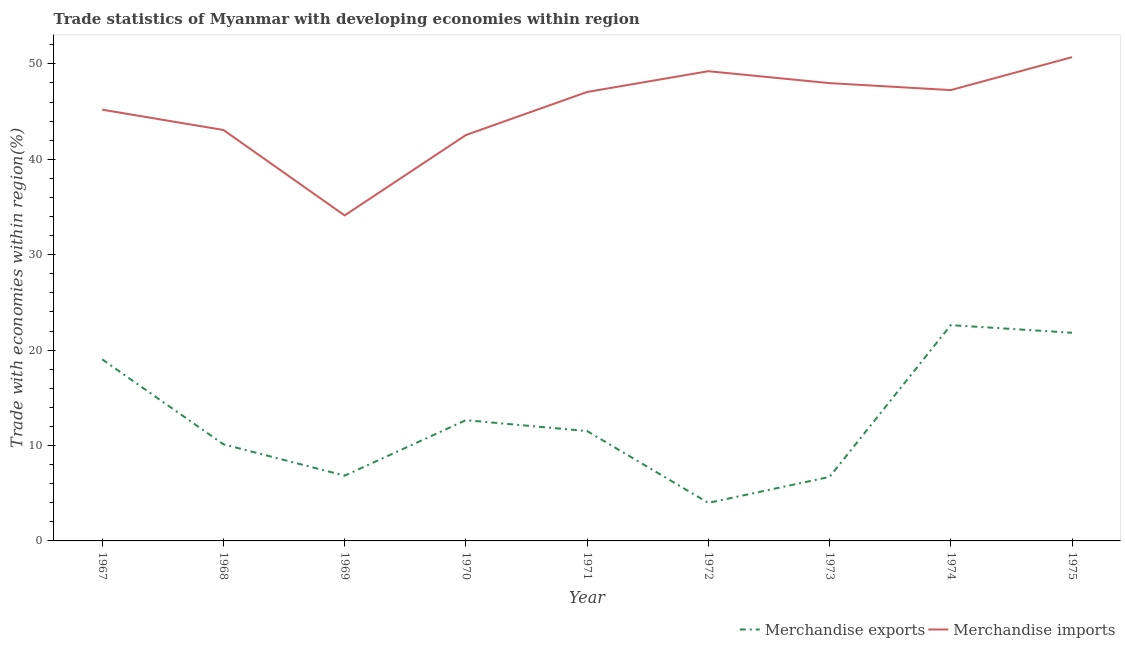Does the line corresponding to merchandise imports intersect with the line corresponding to merchandise exports?
Your response must be concise. No. What is the merchandise exports in 1970?
Keep it short and to the point. 12.65. Across all years, what is the maximum merchandise exports?
Provide a short and direct response. 22.62. Across all years, what is the minimum merchandise imports?
Your response must be concise. 34.12. In which year was the merchandise exports maximum?
Provide a short and direct response. 1974. In which year was the merchandise imports minimum?
Give a very brief answer. 1969. What is the total merchandise imports in the graph?
Offer a terse response. 407.14. What is the difference between the merchandise imports in 1971 and that in 1972?
Offer a very short reply. -2.18. What is the difference between the merchandise exports in 1971 and the merchandise imports in 1970?
Provide a short and direct response. -31.02. What is the average merchandise exports per year?
Your answer should be very brief. 12.81. In the year 1967, what is the difference between the merchandise exports and merchandise imports?
Your answer should be very brief. -26.17. What is the ratio of the merchandise exports in 1969 to that in 1975?
Your answer should be very brief. 0.31. Is the merchandise imports in 1968 less than that in 1975?
Your answer should be very brief. Yes. What is the difference between the highest and the second highest merchandise exports?
Provide a short and direct response. 0.8. What is the difference between the highest and the lowest merchandise exports?
Your answer should be very brief. 18.63. In how many years, is the merchandise imports greater than the average merchandise imports taken over all years?
Your answer should be compact. 5. Is the sum of the merchandise exports in 1967 and 1973 greater than the maximum merchandise imports across all years?
Offer a very short reply. No. Does the merchandise imports monotonically increase over the years?
Provide a succinct answer. No. Is the merchandise exports strictly less than the merchandise imports over the years?
Your answer should be very brief. Yes. How many years are there in the graph?
Ensure brevity in your answer.  9. What is the difference between two consecutive major ticks on the Y-axis?
Your answer should be very brief. 10. How are the legend labels stacked?
Your answer should be very brief. Horizontal. What is the title of the graph?
Offer a terse response. Trade statistics of Myanmar with developing economies within region. What is the label or title of the X-axis?
Your answer should be compact. Year. What is the label or title of the Y-axis?
Make the answer very short. Trade with economies within region(%). What is the Trade with economies within region(%) in Merchandise exports in 1967?
Keep it short and to the point. 19.03. What is the Trade with economies within region(%) in Merchandise imports in 1967?
Provide a short and direct response. 45.2. What is the Trade with economies within region(%) of Merchandise exports in 1968?
Your answer should be compact. 10.13. What is the Trade with economies within region(%) of Merchandise imports in 1968?
Offer a very short reply. 43.07. What is the Trade with economies within region(%) in Merchandise exports in 1969?
Provide a short and direct response. 6.84. What is the Trade with economies within region(%) in Merchandise imports in 1969?
Ensure brevity in your answer.  34.12. What is the Trade with economies within region(%) in Merchandise exports in 1970?
Your answer should be very brief. 12.65. What is the Trade with economies within region(%) in Merchandise imports in 1970?
Ensure brevity in your answer.  42.54. What is the Trade with economies within region(%) of Merchandise exports in 1971?
Provide a short and direct response. 11.52. What is the Trade with economies within region(%) in Merchandise imports in 1971?
Your answer should be very brief. 47.05. What is the Trade with economies within region(%) of Merchandise exports in 1972?
Your answer should be compact. 3.99. What is the Trade with economies within region(%) of Merchandise imports in 1972?
Provide a short and direct response. 49.23. What is the Trade with economies within region(%) in Merchandise exports in 1973?
Your response must be concise. 6.71. What is the Trade with economies within region(%) of Merchandise imports in 1973?
Offer a terse response. 47.98. What is the Trade with economies within region(%) of Merchandise exports in 1974?
Provide a short and direct response. 22.62. What is the Trade with economies within region(%) of Merchandise imports in 1974?
Your answer should be very brief. 47.25. What is the Trade with economies within region(%) of Merchandise exports in 1975?
Provide a short and direct response. 21.82. What is the Trade with economies within region(%) of Merchandise imports in 1975?
Your response must be concise. 50.7. Across all years, what is the maximum Trade with economies within region(%) of Merchandise exports?
Give a very brief answer. 22.62. Across all years, what is the maximum Trade with economies within region(%) in Merchandise imports?
Offer a very short reply. 50.7. Across all years, what is the minimum Trade with economies within region(%) of Merchandise exports?
Offer a terse response. 3.99. Across all years, what is the minimum Trade with economies within region(%) of Merchandise imports?
Keep it short and to the point. 34.12. What is the total Trade with economies within region(%) in Merchandise exports in the graph?
Your answer should be very brief. 115.3. What is the total Trade with economies within region(%) of Merchandise imports in the graph?
Provide a succinct answer. 407.14. What is the difference between the Trade with economies within region(%) of Merchandise exports in 1967 and that in 1968?
Keep it short and to the point. 8.9. What is the difference between the Trade with economies within region(%) in Merchandise imports in 1967 and that in 1968?
Your answer should be compact. 2.13. What is the difference between the Trade with economies within region(%) in Merchandise exports in 1967 and that in 1969?
Provide a short and direct response. 12.19. What is the difference between the Trade with economies within region(%) in Merchandise imports in 1967 and that in 1969?
Offer a very short reply. 11.08. What is the difference between the Trade with economies within region(%) in Merchandise exports in 1967 and that in 1970?
Provide a succinct answer. 6.37. What is the difference between the Trade with economies within region(%) of Merchandise imports in 1967 and that in 1970?
Your answer should be very brief. 2.66. What is the difference between the Trade with economies within region(%) in Merchandise exports in 1967 and that in 1971?
Offer a terse response. 7.51. What is the difference between the Trade with economies within region(%) in Merchandise imports in 1967 and that in 1971?
Your answer should be very brief. -1.86. What is the difference between the Trade with economies within region(%) in Merchandise exports in 1967 and that in 1972?
Your answer should be compact. 15.04. What is the difference between the Trade with economies within region(%) in Merchandise imports in 1967 and that in 1972?
Offer a terse response. -4.03. What is the difference between the Trade with economies within region(%) in Merchandise exports in 1967 and that in 1973?
Your answer should be very brief. 12.32. What is the difference between the Trade with economies within region(%) in Merchandise imports in 1967 and that in 1973?
Your answer should be compact. -2.78. What is the difference between the Trade with economies within region(%) of Merchandise exports in 1967 and that in 1974?
Make the answer very short. -3.59. What is the difference between the Trade with economies within region(%) of Merchandise imports in 1967 and that in 1974?
Give a very brief answer. -2.05. What is the difference between the Trade with economies within region(%) of Merchandise exports in 1967 and that in 1975?
Your response must be concise. -2.79. What is the difference between the Trade with economies within region(%) of Merchandise imports in 1967 and that in 1975?
Make the answer very short. -5.5. What is the difference between the Trade with economies within region(%) of Merchandise exports in 1968 and that in 1969?
Your answer should be very brief. 3.29. What is the difference between the Trade with economies within region(%) of Merchandise imports in 1968 and that in 1969?
Your response must be concise. 8.96. What is the difference between the Trade with economies within region(%) in Merchandise exports in 1968 and that in 1970?
Make the answer very short. -2.53. What is the difference between the Trade with economies within region(%) of Merchandise imports in 1968 and that in 1970?
Your answer should be very brief. 0.53. What is the difference between the Trade with economies within region(%) of Merchandise exports in 1968 and that in 1971?
Your response must be concise. -1.39. What is the difference between the Trade with economies within region(%) in Merchandise imports in 1968 and that in 1971?
Give a very brief answer. -3.98. What is the difference between the Trade with economies within region(%) in Merchandise exports in 1968 and that in 1972?
Keep it short and to the point. 6.14. What is the difference between the Trade with economies within region(%) of Merchandise imports in 1968 and that in 1972?
Offer a very short reply. -6.16. What is the difference between the Trade with economies within region(%) of Merchandise exports in 1968 and that in 1973?
Ensure brevity in your answer.  3.42. What is the difference between the Trade with economies within region(%) of Merchandise imports in 1968 and that in 1973?
Your answer should be compact. -4.91. What is the difference between the Trade with economies within region(%) in Merchandise exports in 1968 and that in 1974?
Keep it short and to the point. -12.49. What is the difference between the Trade with economies within region(%) of Merchandise imports in 1968 and that in 1974?
Make the answer very short. -4.18. What is the difference between the Trade with economies within region(%) of Merchandise exports in 1968 and that in 1975?
Ensure brevity in your answer.  -11.69. What is the difference between the Trade with economies within region(%) in Merchandise imports in 1968 and that in 1975?
Provide a succinct answer. -7.63. What is the difference between the Trade with economies within region(%) in Merchandise exports in 1969 and that in 1970?
Keep it short and to the point. -5.82. What is the difference between the Trade with economies within region(%) in Merchandise imports in 1969 and that in 1970?
Ensure brevity in your answer.  -8.42. What is the difference between the Trade with economies within region(%) of Merchandise exports in 1969 and that in 1971?
Your response must be concise. -4.68. What is the difference between the Trade with economies within region(%) of Merchandise imports in 1969 and that in 1971?
Provide a short and direct response. -12.94. What is the difference between the Trade with economies within region(%) in Merchandise exports in 1969 and that in 1972?
Offer a terse response. 2.85. What is the difference between the Trade with economies within region(%) in Merchandise imports in 1969 and that in 1972?
Make the answer very short. -15.11. What is the difference between the Trade with economies within region(%) of Merchandise exports in 1969 and that in 1973?
Offer a very short reply. 0.13. What is the difference between the Trade with economies within region(%) of Merchandise imports in 1969 and that in 1973?
Your answer should be very brief. -13.86. What is the difference between the Trade with economies within region(%) of Merchandise exports in 1969 and that in 1974?
Keep it short and to the point. -15.78. What is the difference between the Trade with economies within region(%) in Merchandise imports in 1969 and that in 1974?
Ensure brevity in your answer.  -13.14. What is the difference between the Trade with economies within region(%) in Merchandise exports in 1969 and that in 1975?
Ensure brevity in your answer.  -14.98. What is the difference between the Trade with economies within region(%) in Merchandise imports in 1969 and that in 1975?
Offer a very short reply. -16.59. What is the difference between the Trade with economies within region(%) of Merchandise exports in 1970 and that in 1971?
Ensure brevity in your answer.  1.14. What is the difference between the Trade with economies within region(%) of Merchandise imports in 1970 and that in 1971?
Your response must be concise. -4.51. What is the difference between the Trade with economies within region(%) of Merchandise exports in 1970 and that in 1972?
Your answer should be very brief. 8.67. What is the difference between the Trade with economies within region(%) in Merchandise imports in 1970 and that in 1972?
Your answer should be very brief. -6.69. What is the difference between the Trade with economies within region(%) of Merchandise exports in 1970 and that in 1973?
Provide a succinct answer. 5.94. What is the difference between the Trade with economies within region(%) of Merchandise imports in 1970 and that in 1973?
Provide a succinct answer. -5.44. What is the difference between the Trade with economies within region(%) in Merchandise exports in 1970 and that in 1974?
Give a very brief answer. -9.96. What is the difference between the Trade with economies within region(%) of Merchandise imports in 1970 and that in 1974?
Make the answer very short. -4.71. What is the difference between the Trade with economies within region(%) of Merchandise exports in 1970 and that in 1975?
Provide a succinct answer. -9.16. What is the difference between the Trade with economies within region(%) of Merchandise imports in 1970 and that in 1975?
Your response must be concise. -8.16. What is the difference between the Trade with economies within region(%) in Merchandise exports in 1971 and that in 1972?
Make the answer very short. 7.53. What is the difference between the Trade with economies within region(%) of Merchandise imports in 1971 and that in 1972?
Offer a very short reply. -2.18. What is the difference between the Trade with economies within region(%) in Merchandise exports in 1971 and that in 1973?
Your answer should be very brief. 4.8. What is the difference between the Trade with economies within region(%) in Merchandise imports in 1971 and that in 1973?
Ensure brevity in your answer.  -0.93. What is the difference between the Trade with economies within region(%) in Merchandise exports in 1971 and that in 1974?
Provide a short and direct response. -11.1. What is the difference between the Trade with economies within region(%) in Merchandise imports in 1971 and that in 1974?
Your response must be concise. -0.2. What is the difference between the Trade with economies within region(%) in Merchandise exports in 1971 and that in 1975?
Provide a succinct answer. -10.3. What is the difference between the Trade with economies within region(%) of Merchandise imports in 1971 and that in 1975?
Your answer should be very brief. -3.65. What is the difference between the Trade with economies within region(%) in Merchandise exports in 1972 and that in 1973?
Keep it short and to the point. -2.73. What is the difference between the Trade with economies within region(%) of Merchandise imports in 1972 and that in 1973?
Your response must be concise. 1.25. What is the difference between the Trade with economies within region(%) in Merchandise exports in 1972 and that in 1974?
Provide a short and direct response. -18.63. What is the difference between the Trade with economies within region(%) in Merchandise imports in 1972 and that in 1974?
Keep it short and to the point. 1.98. What is the difference between the Trade with economies within region(%) in Merchandise exports in 1972 and that in 1975?
Keep it short and to the point. -17.83. What is the difference between the Trade with economies within region(%) of Merchandise imports in 1972 and that in 1975?
Offer a very short reply. -1.47. What is the difference between the Trade with economies within region(%) in Merchandise exports in 1973 and that in 1974?
Offer a terse response. -15.9. What is the difference between the Trade with economies within region(%) of Merchandise imports in 1973 and that in 1974?
Offer a terse response. 0.73. What is the difference between the Trade with economies within region(%) of Merchandise exports in 1973 and that in 1975?
Offer a terse response. -15.11. What is the difference between the Trade with economies within region(%) in Merchandise imports in 1973 and that in 1975?
Offer a very short reply. -2.72. What is the difference between the Trade with economies within region(%) in Merchandise exports in 1974 and that in 1975?
Offer a very short reply. 0.8. What is the difference between the Trade with economies within region(%) of Merchandise imports in 1974 and that in 1975?
Make the answer very short. -3.45. What is the difference between the Trade with economies within region(%) in Merchandise exports in 1967 and the Trade with economies within region(%) in Merchandise imports in 1968?
Make the answer very short. -24.04. What is the difference between the Trade with economies within region(%) in Merchandise exports in 1967 and the Trade with economies within region(%) in Merchandise imports in 1969?
Provide a succinct answer. -15.09. What is the difference between the Trade with economies within region(%) in Merchandise exports in 1967 and the Trade with economies within region(%) in Merchandise imports in 1970?
Provide a succinct answer. -23.51. What is the difference between the Trade with economies within region(%) in Merchandise exports in 1967 and the Trade with economies within region(%) in Merchandise imports in 1971?
Ensure brevity in your answer.  -28.03. What is the difference between the Trade with economies within region(%) in Merchandise exports in 1967 and the Trade with economies within region(%) in Merchandise imports in 1972?
Offer a very short reply. -30.2. What is the difference between the Trade with economies within region(%) in Merchandise exports in 1967 and the Trade with economies within region(%) in Merchandise imports in 1973?
Your answer should be very brief. -28.95. What is the difference between the Trade with economies within region(%) of Merchandise exports in 1967 and the Trade with economies within region(%) of Merchandise imports in 1974?
Provide a succinct answer. -28.22. What is the difference between the Trade with economies within region(%) in Merchandise exports in 1967 and the Trade with economies within region(%) in Merchandise imports in 1975?
Provide a short and direct response. -31.67. What is the difference between the Trade with economies within region(%) of Merchandise exports in 1968 and the Trade with economies within region(%) of Merchandise imports in 1969?
Your answer should be very brief. -23.99. What is the difference between the Trade with economies within region(%) of Merchandise exports in 1968 and the Trade with economies within region(%) of Merchandise imports in 1970?
Keep it short and to the point. -32.41. What is the difference between the Trade with economies within region(%) of Merchandise exports in 1968 and the Trade with economies within region(%) of Merchandise imports in 1971?
Offer a very short reply. -36.93. What is the difference between the Trade with economies within region(%) in Merchandise exports in 1968 and the Trade with economies within region(%) in Merchandise imports in 1972?
Provide a short and direct response. -39.1. What is the difference between the Trade with economies within region(%) in Merchandise exports in 1968 and the Trade with economies within region(%) in Merchandise imports in 1973?
Make the answer very short. -37.85. What is the difference between the Trade with economies within region(%) in Merchandise exports in 1968 and the Trade with economies within region(%) in Merchandise imports in 1974?
Give a very brief answer. -37.12. What is the difference between the Trade with economies within region(%) of Merchandise exports in 1968 and the Trade with economies within region(%) of Merchandise imports in 1975?
Your answer should be compact. -40.57. What is the difference between the Trade with economies within region(%) of Merchandise exports in 1969 and the Trade with economies within region(%) of Merchandise imports in 1970?
Your answer should be very brief. -35.7. What is the difference between the Trade with economies within region(%) of Merchandise exports in 1969 and the Trade with economies within region(%) of Merchandise imports in 1971?
Your answer should be very brief. -40.21. What is the difference between the Trade with economies within region(%) of Merchandise exports in 1969 and the Trade with economies within region(%) of Merchandise imports in 1972?
Your response must be concise. -42.39. What is the difference between the Trade with economies within region(%) of Merchandise exports in 1969 and the Trade with economies within region(%) of Merchandise imports in 1973?
Make the answer very short. -41.14. What is the difference between the Trade with economies within region(%) of Merchandise exports in 1969 and the Trade with economies within region(%) of Merchandise imports in 1974?
Your answer should be very brief. -40.41. What is the difference between the Trade with economies within region(%) in Merchandise exports in 1969 and the Trade with economies within region(%) in Merchandise imports in 1975?
Your response must be concise. -43.86. What is the difference between the Trade with economies within region(%) of Merchandise exports in 1970 and the Trade with economies within region(%) of Merchandise imports in 1971?
Offer a very short reply. -34.4. What is the difference between the Trade with economies within region(%) of Merchandise exports in 1970 and the Trade with economies within region(%) of Merchandise imports in 1972?
Your answer should be compact. -36.58. What is the difference between the Trade with economies within region(%) in Merchandise exports in 1970 and the Trade with economies within region(%) in Merchandise imports in 1973?
Offer a very short reply. -35.33. What is the difference between the Trade with economies within region(%) of Merchandise exports in 1970 and the Trade with economies within region(%) of Merchandise imports in 1974?
Keep it short and to the point. -34.6. What is the difference between the Trade with economies within region(%) of Merchandise exports in 1970 and the Trade with economies within region(%) of Merchandise imports in 1975?
Your answer should be compact. -38.05. What is the difference between the Trade with economies within region(%) in Merchandise exports in 1971 and the Trade with economies within region(%) in Merchandise imports in 1972?
Make the answer very short. -37.71. What is the difference between the Trade with economies within region(%) in Merchandise exports in 1971 and the Trade with economies within region(%) in Merchandise imports in 1973?
Offer a terse response. -36.46. What is the difference between the Trade with economies within region(%) in Merchandise exports in 1971 and the Trade with economies within region(%) in Merchandise imports in 1974?
Offer a terse response. -35.74. What is the difference between the Trade with economies within region(%) in Merchandise exports in 1971 and the Trade with economies within region(%) in Merchandise imports in 1975?
Provide a succinct answer. -39.19. What is the difference between the Trade with economies within region(%) in Merchandise exports in 1972 and the Trade with economies within region(%) in Merchandise imports in 1973?
Make the answer very short. -43.99. What is the difference between the Trade with economies within region(%) in Merchandise exports in 1972 and the Trade with economies within region(%) in Merchandise imports in 1974?
Offer a very short reply. -43.27. What is the difference between the Trade with economies within region(%) in Merchandise exports in 1972 and the Trade with economies within region(%) in Merchandise imports in 1975?
Offer a terse response. -46.72. What is the difference between the Trade with economies within region(%) of Merchandise exports in 1973 and the Trade with economies within region(%) of Merchandise imports in 1974?
Your answer should be very brief. -40.54. What is the difference between the Trade with economies within region(%) in Merchandise exports in 1973 and the Trade with economies within region(%) in Merchandise imports in 1975?
Your answer should be compact. -43.99. What is the difference between the Trade with economies within region(%) in Merchandise exports in 1974 and the Trade with economies within region(%) in Merchandise imports in 1975?
Provide a succinct answer. -28.09. What is the average Trade with economies within region(%) of Merchandise exports per year?
Make the answer very short. 12.81. What is the average Trade with economies within region(%) of Merchandise imports per year?
Offer a very short reply. 45.24. In the year 1967, what is the difference between the Trade with economies within region(%) of Merchandise exports and Trade with economies within region(%) of Merchandise imports?
Offer a terse response. -26.17. In the year 1968, what is the difference between the Trade with economies within region(%) in Merchandise exports and Trade with economies within region(%) in Merchandise imports?
Keep it short and to the point. -32.94. In the year 1969, what is the difference between the Trade with economies within region(%) of Merchandise exports and Trade with economies within region(%) of Merchandise imports?
Offer a very short reply. -27.28. In the year 1970, what is the difference between the Trade with economies within region(%) in Merchandise exports and Trade with economies within region(%) in Merchandise imports?
Your answer should be compact. -29.88. In the year 1971, what is the difference between the Trade with economies within region(%) of Merchandise exports and Trade with economies within region(%) of Merchandise imports?
Your response must be concise. -35.54. In the year 1972, what is the difference between the Trade with economies within region(%) in Merchandise exports and Trade with economies within region(%) in Merchandise imports?
Your answer should be very brief. -45.24. In the year 1973, what is the difference between the Trade with economies within region(%) of Merchandise exports and Trade with economies within region(%) of Merchandise imports?
Give a very brief answer. -41.27. In the year 1974, what is the difference between the Trade with economies within region(%) of Merchandise exports and Trade with economies within region(%) of Merchandise imports?
Offer a very short reply. -24.64. In the year 1975, what is the difference between the Trade with economies within region(%) in Merchandise exports and Trade with economies within region(%) in Merchandise imports?
Keep it short and to the point. -28.88. What is the ratio of the Trade with economies within region(%) in Merchandise exports in 1967 to that in 1968?
Keep it short and to the point. 1.88. What is the ratio of the Trade with economies within region(%) in Merchandise imports in 1967 to that in 1968?
Your answer should be very brief. 1.05. What is the ratio of the Trade with economies within region(%) in Merchandise exports in 1967 to that in 1969?
Provide a short and direct response. 2.78. What is the ratio of the Trade with economies within region(%) of Merchandise imports in 1967 to that in 1969?
Your answer should be compact. 1.32. What is the ratio of the Trade with economies within region(%) in Merchandise exports in 1967 to that in 1970?
Keep it short and to the point. 1.5. What is the ratio of the Trade with economies within region(%) in Merchandise exports in 1967 to that in 1971?
Make the answer very short. 1.65. What is the ratio of the Trade with economies within region(%) in Merchandise imports in 1967 to that in 1971?
Provide a succinct answer. 0.96. What is the ratio of the Trade with economies within region(%) of Merchandise exports in 1967 to that in 1972?
Your answer should be very brief. 4.77. What is the ratio of the Trade with economies within region(%) of Merchandise imports in 1967 to that in 1972?
Offer a very short reply. 0.92. What is the ratio of the Trade with economies within region(%) of Merchandise exports in 1967 to that in 1973?
Offer a very short reply. 2.83. What is the ratio of the Trade with economies within region(%) of Merchandise imports in 1967 to that in 1973?
Make the answer very short. 0.94. What is the ratio of the Trade with economies within region(%) of Merchandise exports in 1967 to that in 1974?
Offer a very short reply. 0.84. What is the ratio of the Trade with economies within region(%) of Merchandise imports in 1967 to that in 1974?
Give a very brief answer. 0.96. What is the ratio of the Trade with economies within region(%) of Merchandise exports in 1967 to that in 1975?
Give a very brief answer. 0.87. What is the ratio of the Trade with economies within region(%) of Merchandise imports in 1967 to that in 1975?
Your answer should be compact. 0.89. What is the ratio of the Trade with economies within region(%) of Merchandise exports in 1968 to that in 1969?
Provide a short and direct response. 1.48. What is the ratio of the Trade with economies within region(%) in Merchandise imports in 1968 to that in 1969?
Provide a short and direct response. 1.26. What is the ratio of the Trade with economies within region(%) in Merchandise exports in 1968 to that in 1970?
Ensure brevity in your answer.  0.8. What is the ratio of the Trade with economies within region(%) of Merchandise imports in 1968 to that in 1970?
Make the answer very short. 1.01. What is the ratio of the Trade with economies within region(%) in Merchandise exports in 1968 to that in 1971?
Offer a very short reply. 0.88. What is the ratio of the Trade with economies within region(%) of Merchandise imports in 1968 to that in 1971?
Keep it short and to the point. 0.92. What is the ratio of the Trade with economies within region(%) of Merchandise exports in 1968 to that in 1972?
Your answer should be very brief. 2.54. What is the ratio of the Trade with economies within region(%) of Merchandise imports in 1968 to that in 1972?
Provide a short and direct response. 0.87. What is the ratio of the Trade with economies within region(%) in Merchandise exports in 1968 to that in 1973?
Provide a succinct answer. 1.51. What is the ratio of the Trade with economies within region(%) in Merchandise imports in 1968 to that in 1973?
Your answer should be very brief. 0.9. What is the ratio of the Trade with economies within region(%) in Merchandise exports in 1968 to that in 1974?
Give a very brief answer. 0.45. What is the ratio of the Trade with economies within region(%) of Merchandise imports in 1968 to that in 1974?
Keep it short and to the point. 0.91. What is the ratio of the Trade with economies within region(%) in Merchandise exports in 1968 to that in 1975?
Your answer should be compact. 0.46. What is the ratio of the Trade with economies within region(%) of Merchandise imports in 1968 to that in 1975?
Your response must be concise. 0.85. What is the ratio of the Trade with economies within region(%) in Merchandise exports in 1969 to that in 1970?
Ensure brevity in your answer.  0.54. What is the ratio of the Trade with economies within region(%) of Merchandise imports in 1969 to that in 1970?
Keep it short and to the point. 0.8. What is the ratio of the Trade with economies within region(%) of Merchandise exports in 1969 to that in 1971?
Your response must be concise. 0.59. What is the ratio of the Trade with economies within region(%) in Merchandise imports in 1969 to that in 1971?
Your answer should be very brief. 0.72. What is the ratio of the Trade with economies within region(%) in Merchandise exports in 1969 to that in 1972?
Your answer should be compact. 1.72. What is the ratio of the Trade with economies within region(%) in Merchandise imports in 1969 to that in 1972?
Keep it short and to the point. 0.69. What is the ratio of the Trade with economies within region(%) of Merchandise exports in 1969 to that in 1973?
Ensure brevity in your answer.  1.02. What is the ratio of the Trade with economies within region(%) of Merchandise imports in 1969 to that in 1973?
Provide a short and direct response. 0.71. What is the ratio of the Trade with economies within region(%) of Merchandise exports in 1969 to that in 1974?
Keep it short and to the point. 0.3. What is the ratio of the Trade with economies within region(%) of Merchandise imports in 1969 to that in 1974?
Make the answer very short. 0.72. What is the ratio of the Trade with economies within region(%) in Merchandise exports in 1969 to that in 1975?
Give a very brief answer. 0.31. What is the ratio of the Trade with economies within region(%) in Merchandise imports in 1969 to that in 1975?
Your answer should be compact. 0.67. What is the ratio of the Trade with economies within region(%) in Merchandise exports in 1970 to that in 1971?
Your answer should be very brief. 1.1. What is the ratio of the Trade with economies within region(%) in Merchandise imports in 1970 to that in 1971?
Your answer should be very brief. 0.9. What is the ratio of the Trade with economies within region(%) of Merchandise exports in 1970 to that in 1972?
Make the answer very short. 3.17. What is the ratio of the Trade with economies within region(%) of Merchandise imports in 1970 to that in 1972?
Make the answer very short. 0.86. What is the ratio of the Trade with economies within region(%) of Merchandise exports in 1970 to that in 1973?
Offer a terse response. 1.89. What is the ratio of the Trade with economies within region(%) of Merchandise imports in 1970 to that in 1973?
Provide a short and direct response. 0.89. What is the ratio of the Trade with economies within region(%) in Merchandise exports in 1970 to that in 1974?
Offer a terse response. 0.56. What is the ratio of the Trade with economies within region(%) in Merchandise imports in 1970 to that in 1974?
Your answer should be compact. 0.9. What is the ratio of the Trade with economies within region(%) of Merchandise exports in 1970 to that in 1975?
Your answer should be compact. 0.58. What is the ratio of the Trade with economies within region(%) of Merchandise imports in 1970 to that in 1975?
Keep it short and to the point. 0.84. What is the ratio of the Trade with economies within region(%) in Merchandise exports in 1971 to that in 1972?
Your response must be concise. 2.89. What is the ratio of the Trade with economies within region(%) of Merchandise imports in 1971 to that in 1972?
Give a very brief answer. 0.96. What is the ratio of the Trade with economies within region(%) in Merchandise exports in 1971 to that in 1973?
Provide a succinct answer. 1.72. What is the ratio of the Trade with economies within region(%) of Merchandise imports in 1971 to that in 1973?
Make the answer very short. 0.98. What is the ratio of the Trade with economies within region(%) in Merchandise exports in 1971 to that in 1974?
Your answer should be very brief. 0.51. What is the ratio of the Trade with economies within region(%) of Merchandise exports in 1971 to that in 1975?
Offer a terse response. 0.53. What is the ratio of the Trade with economies within region(%) of Merchandise imports in 1971 to that in 1975?
Provide a short and direct response. 0.93. What is the ratio of the Trade with economies within region(%) in Merchandise exports in 1972 to that in 1973?
Offer a terse response. 0.59. What is the ratio of the Trade with economies within region(%) in Merchandise exports in 1972 to that in 1974?
Your response must be concise. 0.18. What is the ratio of the Trade with economies within region(%) in Merchandise imports in 1972 to that in 1974?
Make the answer very short. 1.04. What is the ratio of the Trade with economies within region(%) in Merchandise exports in 1972 to that in 1975?
Offer a very short reply. 0.18. What is the ratio of the Trade with economies within region(%) of Merchandise exports in 1973 to that in 1974?
Ensure brevity in your answer.  0.3. What is the ratio of the Trade with economies within region(%) in Merchandise imports in 1973 to that in 1974?
Ensure brevity in your answer.  1.02. What is the ratio of the Trade with economies within region(%) of Merchandise exports in 1973 to that in 1975?
Make the answer very short. 0.31. What is the ratio of the Trade with economies within region(%) in Merchandise imports in 1973 to that in 1975?
Give a very brief answer. 0.95. What is the ratio of the Trade with economies within region(%) in Merchandise exports in 1974 to that in 1975?
Your answer should be compact. 1.04. What is the ratio of the Trade with economies within region(%) of Merchandise imports in 1974 to that in 1975?
Your answer should be very brief. 0.93. What is the difference between the highest and the second highest Trade with economies within region(%) in Merchandise exports?
Give a very brief answer. 0.8. What is the difference between the highest and the second highest Trade with economies within region(%) in Merchandise imports?
Provide a succinct answer. 1.47. What is the difference between the highest and the lowest Trade with economies within region(%) in Merchandise exports?
Give a very brief answer. 18.63. What is the difference between the highest and the lowest Trade with economies within region(%) of Merchandise imports?
Your response must be concise. 16.59. 